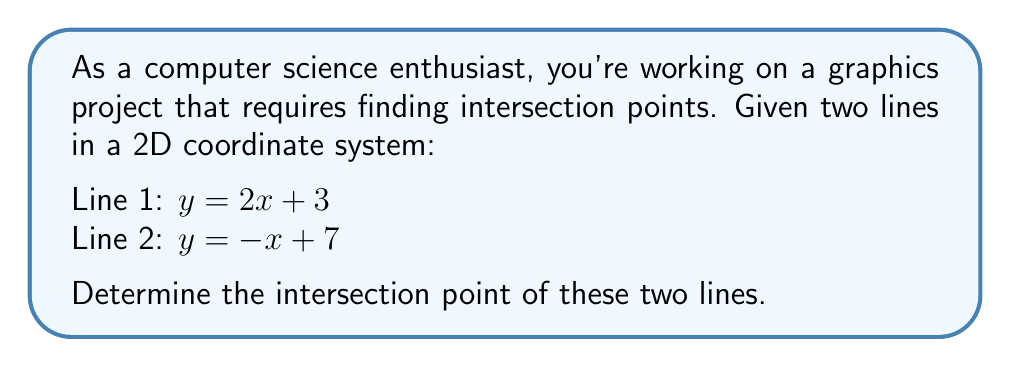Teach me how to tackle this problem. To find the intersection point of two lines, we need to solve the system of equations formed by their equations. Let's approach this step-by-step:

1) We have two equations:
   $y = 2x + 3$ (Line 1)
   $y = -x + 7$ (Line 2)

2) At the intersection point, the y-values will be equal. So we can set the right sides of these equations equal to each other:

   $2x + 3 = -x + 7$

3) Now we can solve this equation for x:
   $2x + 3 = -x + 7$
   $3x = 4$
   $x = \frac{4}{3}$

4) Now that we know the x-coordinate of the intersection point, we can find the y-coordinate by plugging this x-value into either of the original equations. Let's use Line 1:

   $y = 2(\frac{4}{3}) + 3$
   $y = \frac{8}{3} + 3$
   $y = \frac{8}{3} + \frac{9}{3}$
   $y = \frac{17}{3}$

5) Therefore, the intersection point is $(\frac{4}{3}, \frac{17}{3})$.

To verify, we can plug this point into both original equations:

Line 1: $\frac{17}{3} = 2(\frac{4}{3}) + 3 = \frac{8}{3} + 3 = \frac{17}{3}$ ✓
Line 2: $\frac{17}{3} = -(\frac{4}{3}) + 7 = -\frac{4}{3} + \frac{21}{3} = \frac{17}{3}$ ✓

[asy]
unitsize(1cm);
draw((-1,-1)--(5,9),blue);
draw((-1,8)--(8,-1),red);
dot((4/3,17/3),black);
label("(4/3, 17/3)",(4/3,17/3),NE);
label("y = 2x + 3",(4,9),E,blue);
label("y = -x + 7",(7,0),SE,red);
xaxis(-1,8,Arrow);
yaxis(-1,9,Arrow);
[/asy]
Answer: $(\frac{4}{3}, \frac{17}{3})$ 